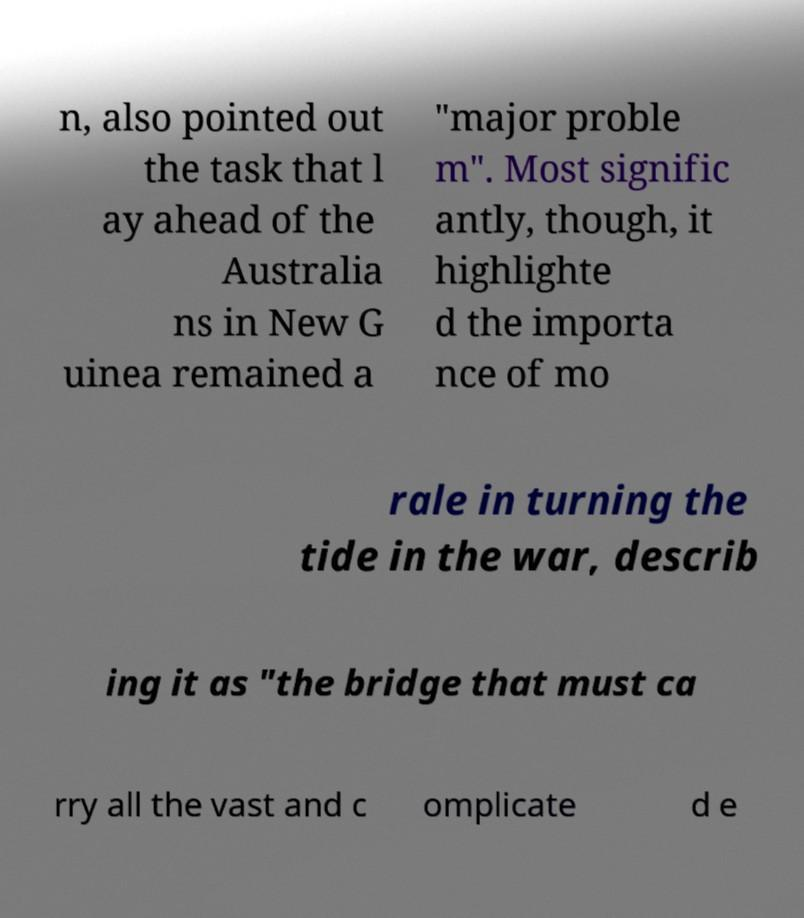What messages or text are displayed in this image? I need them in a readable, typed format. n, also pointed out the task that l ay ahead of the Australia ns in New G uinea remained a "major proble m". Most signific antly, though, it highlighte d the importa nce of mo rale in turning the tide in the war, describ ing it as "the bridge that must ca rry all the vast and c omplicate d e 